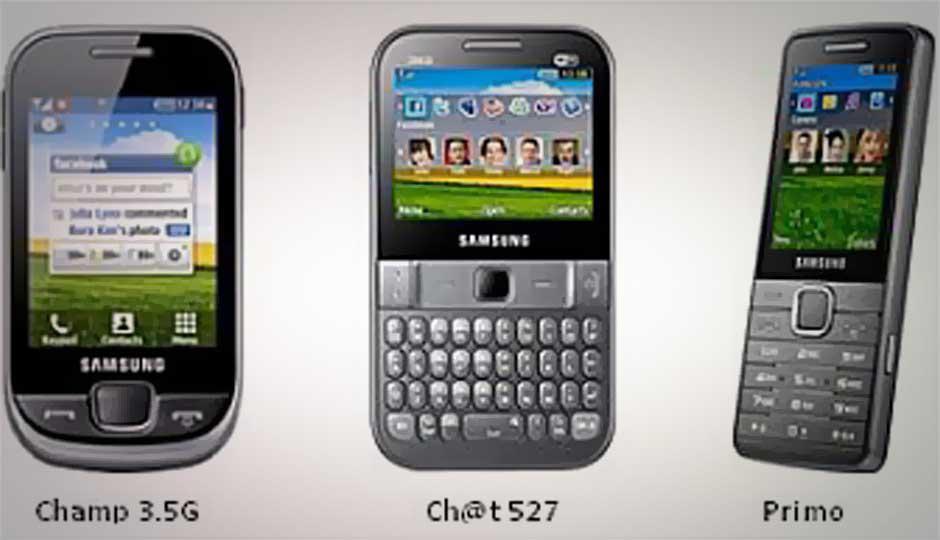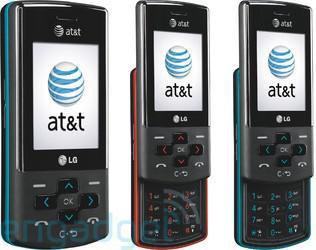The first image is the image on the left, the second image is the image on the right. For the images shown, is this caption "Each image contains exactly three phones, which are displayed vertically facing screen-first and do not have a flip-open top." true? Answer yes or no. Yes. The first image is the image on the left, the second image is the image on the right. Analyze the images presented: Is the assertion "The left and right image contains the same number of vertical phones." valid? Answer yes or no. Yes. 